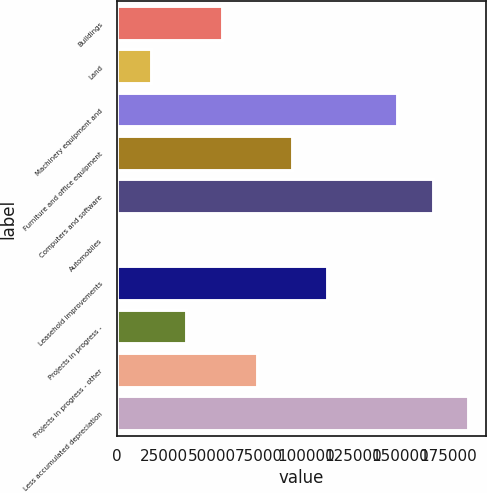Convert chart to OTSL. <chart><loc_0><loc_0><loc_500><loc_500><bar_chart><fcel>Buildings<fcel>Land<fcel>Machinery equipment and<fcel>Furniture and office equipment<fcel>Computers and software<fcel>Automobiles<fcel>Leasehold improvements<fcel>Projects in progress -<fcel>Projects in progress - other<fcel>Less accumulated depreciation<nl><fcel>55836.6<fcel>18624.2<fcel>148868<fcel>93049<fcel>167474<fcel>18<fcel>111655<fcel>37230.4<fcel>74442.8<fcel>186080<nl></chart> 